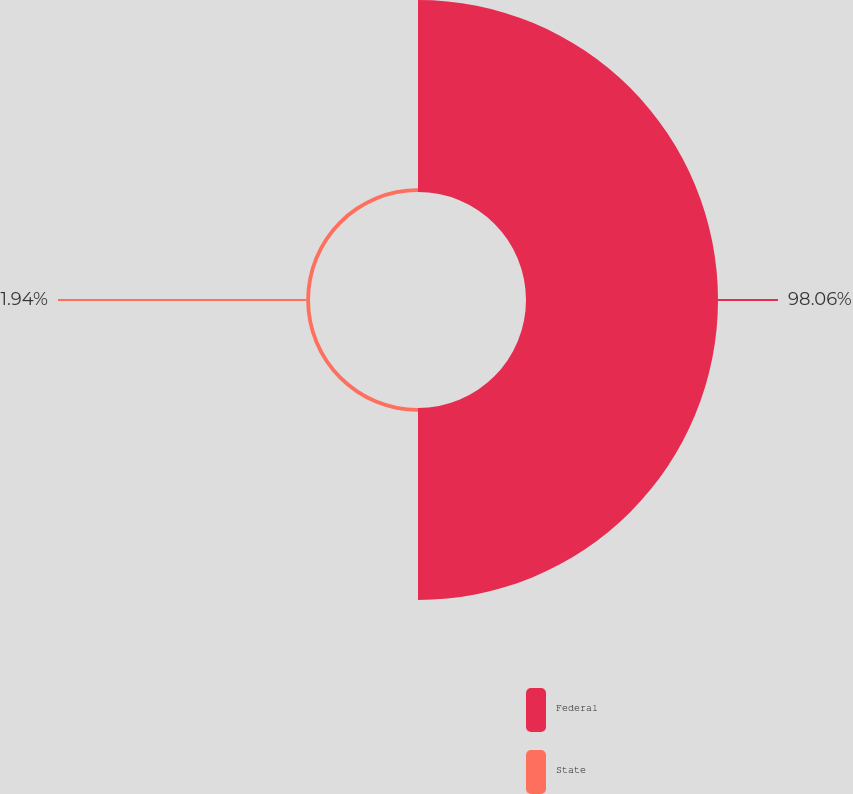Convert chart. <chart><loc_0><loc_0><loc_500><loc_500><pie_chart><fcel>Federal<fcel>State<nl><fcel>98.06%<fcel>1.94%<nl></chart> 